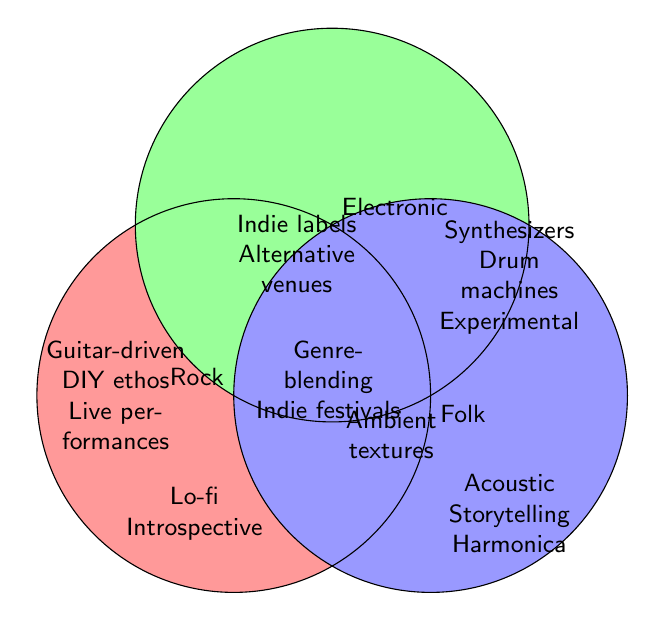What's one unique feature of Folk music? Look at the section labeled "Folk" for distinctive features; the first listed is "Acoustic instruments".
Answer: Acoustic instruments Which genres include "Alternative venues"? The section overlapping Rock and Electronic contains "Alternative venues".
Answer: Rock and Electronic What is located at the center where all three genres overlap? In the central section where Rock, Electronic, and Folk converge, there are "Genre-blending" and "Indie music festivals".
Answer: Genre-blending and Indie music festivals Do Rock and Folk have any common features? The section overlapping Rock and Folk contains shared features; these are "Lo-fi production" and "Introspective themes".
Answer: Lo-fi production and Introspective themes Does the Electronic genre have more unique elements than Folk? Count unique elements: Electronic has "Synthesizers", "Drum machines", and "Experimental sounds"; Folk has "Acoustic instruments", "Storytelling lyrics", and "Harmonica". Both have three unique features.
Answer: No, they have the same number Which two genres share "Ambient textures"? The overlapping area between Electronic and Folk lists "Ambient textures".
Answer: Electronic and Folk What features are found exclusively in the Rock genre? The section labeled "Rock" (not overlapping with others) lists exclusive features like "Guitar-driven", "DIY ethos", and "Live performances".
Answer: Guitar-driven, DIY ethos, Live performances Between Rock and Electronic, which genre is associated with indie labels? The overlapping area between Rock and Electronic has "Indie labels".
Answer: Both Rock and Electronic What feature is shared by Rock, Electronic, but not Folk? Look at the overlapping section between Rock and Electronic but not overlapping with Folk; it contains "Indie labels" and "Alternative venues".
Answer: Indie labels and Alternative venues 